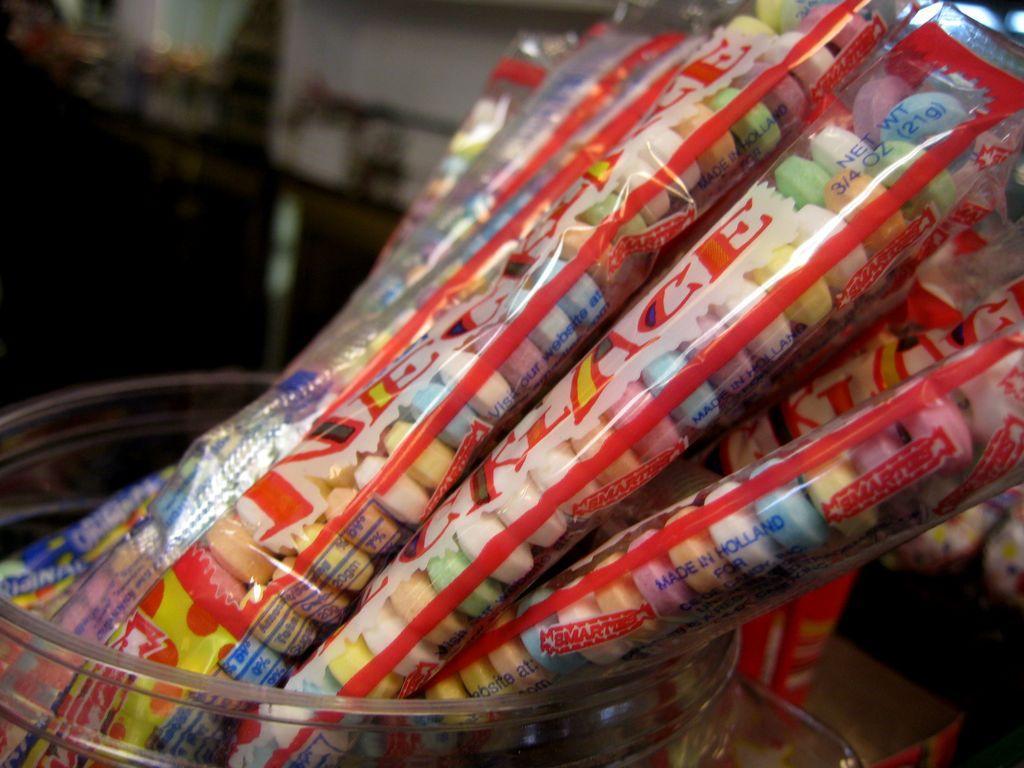Please provide a concise description of this image. In this image I can see few colorful objects inside the packers and these packets are in the container. I can see the blurred background. 